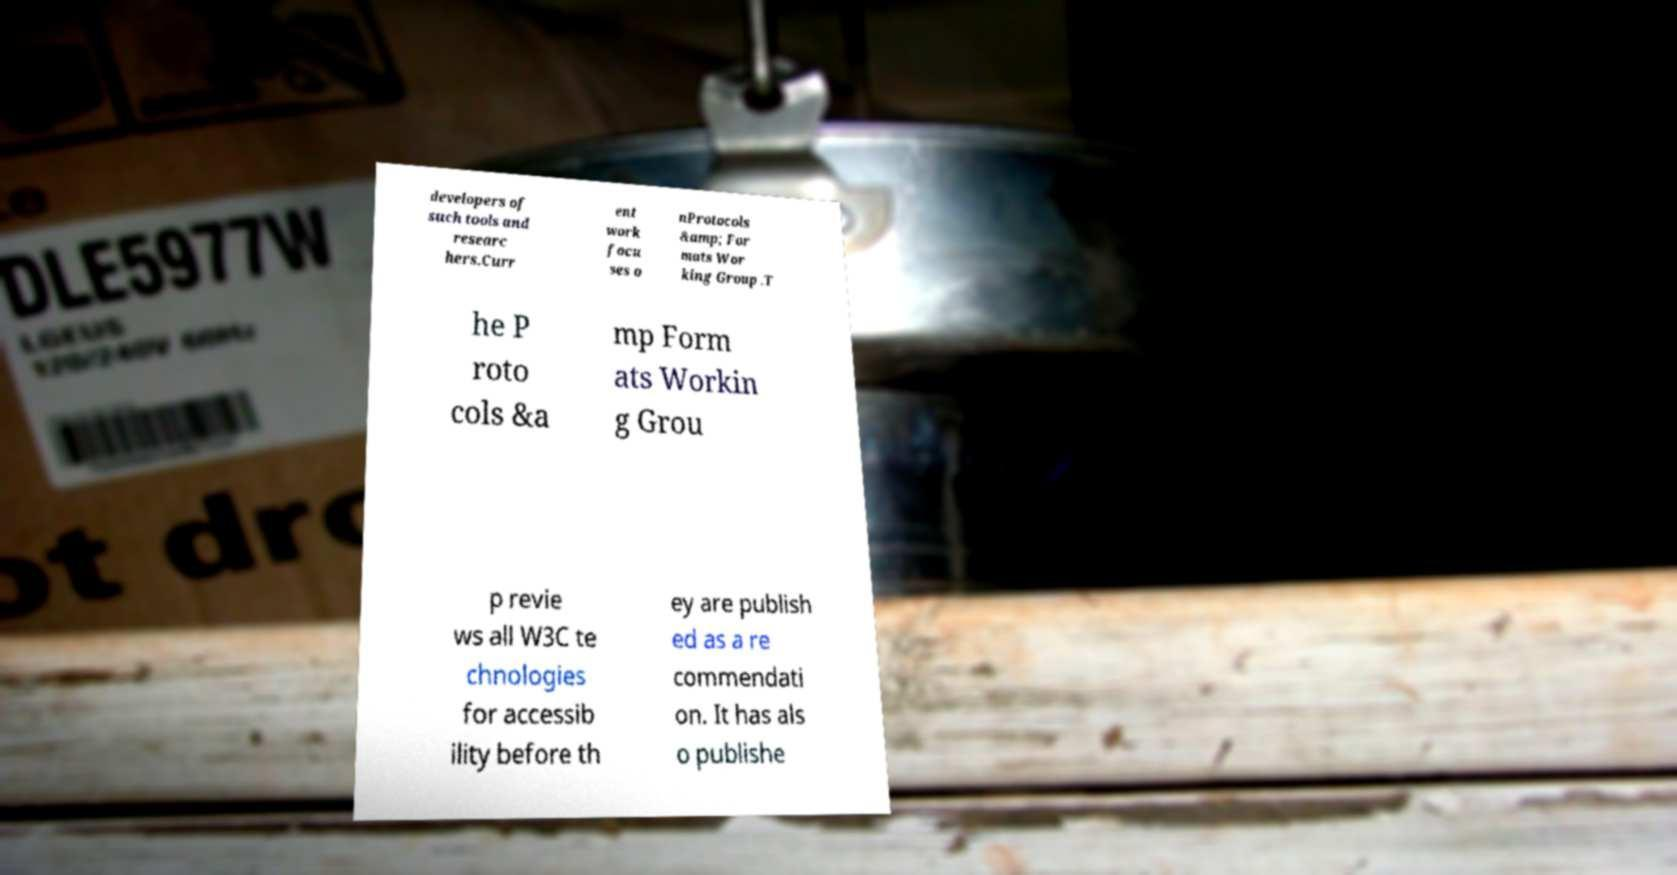Can you read and provide the text displayed in the image?This photo seems to have some interesting text. Can you extract and type it out for me? developers of such tools and researc hers.Curr ent work focu ses o nProtocols &amp; For mats Wor king Group .T he P roto cols &a mp Form ats Workin g Grou p revie ws all W3C te chnologies for accessib ility before th ey are publish ed as a re commendati on. It has als o publishe 